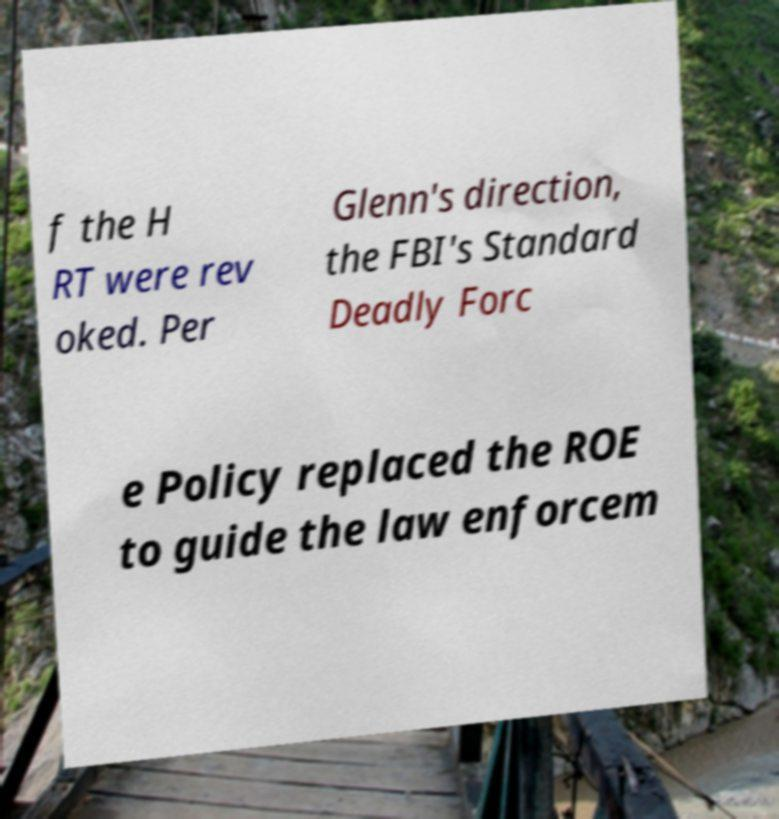Please identify and transcribe the text found in this image. f the H RT were rev oked. Per Glenn's direction, the FBI's Standard Deadly Forc e Policy replaced the ROE to guide the law enforcem 